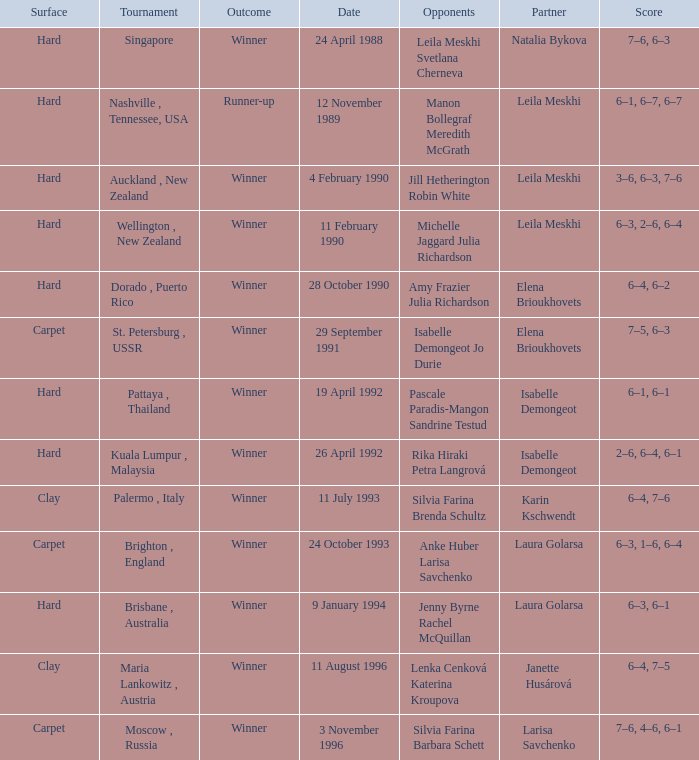On what Date was the Score 6–4, 6–2? 28 October 1990. 